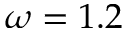Convert formula to latex. <formula><loc_0><loc_0><loc_500><loc_500>\omega = 1 . 2</formula> 